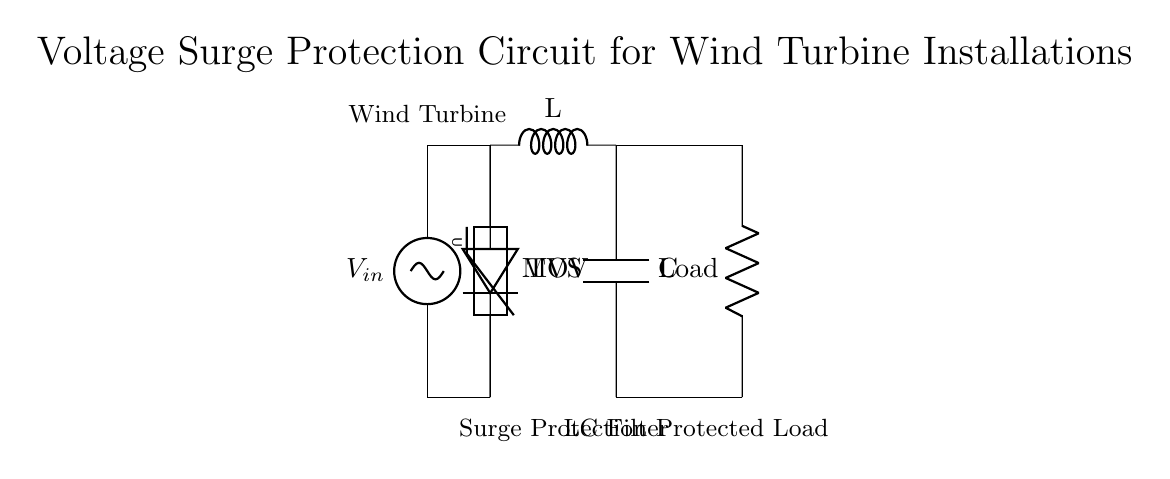What component provides voltage surge protection? The circuit includes a metal oxide varistor (MOV) and a transient voltage suppressor (TVS), both designed to protect against voltage surges.
Answer: MOV and TVS What is the purpose of the LC filter in this circuit? The LC filter smooths out the voltage and current, reducing noise and fluctuations that can occur due to sudden changes in the energy generated by the wind turbine.
Answer: Reduce noise How many components are in the surge protection section? There are two components in the surge protection section: the MOV and the TVS.
Answer: Two What type of load is represented in this circuit? The circuit diagram indicates a resistive load labeled as "Load," which represents the electrical component utilizing the generated power.
Answer: Resistor What do the symbols L and C represent in the LC filter? In the LC filter, "L" represents an inductor, which stores energy in a magnetic field, and "C" represents a capacitor, which stores energy in an electric field.
Answer: Inductor and capacitor What is the relationship between the wind turbine and the surge protection circuit? The wind turbine feeds voltage into the surge protection circuit directly, protecting it from surges before reaching the load.
Answer: Direct connection Which part of the circuit is responsible for filtering? The LC filter, consisting of the inductor (L) and capacitor (C), is responsible for filtering the output to the load.
Answer: LC filter 